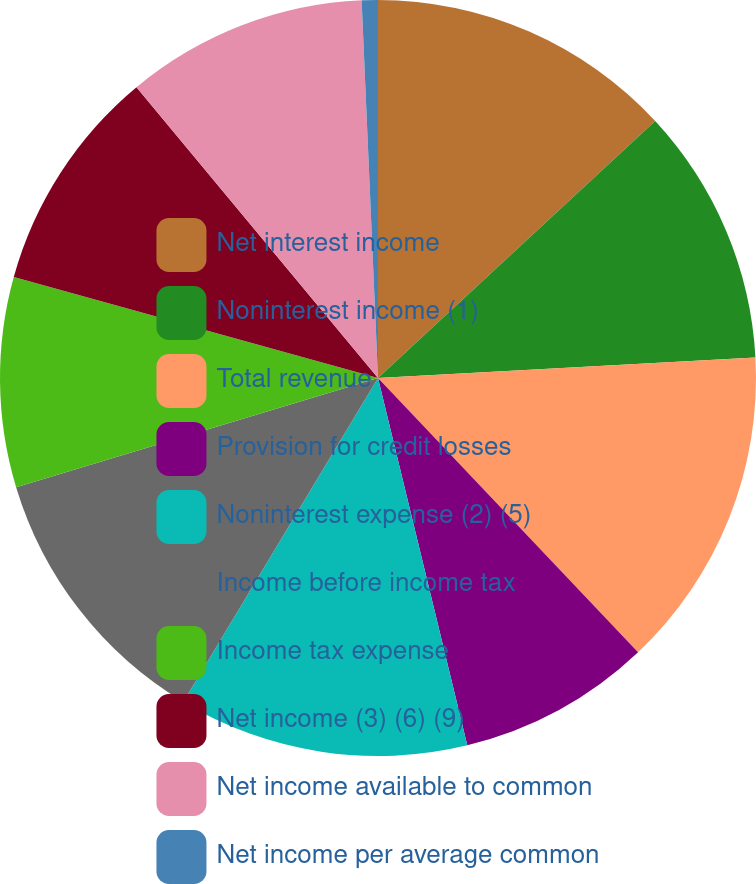Convert chart. <chart><loc_0><loc_0><loc_500><loc_500><pie_chart><fcel>Net interest income<fcel>Noninterest income (1)<fcel>Total revenue<fcel>Provision for credit losses<fcel>Noninterest expense (2) (5)<fcel>Income before income tax<fcel>Income tax expense<fcel>Net income (3) (6) (9)<fcel>Net income available to common<fcel>Net income per average common<nl><fcel>13.1%<fcel>11.03%<fcel>13.79%<fcel>8.28%<fcel>12.41%<fcel>11.72%<fcel>8.97%<fcel>9.66%<fcel>10.34%<fcel>0.69%<nl></chart> 